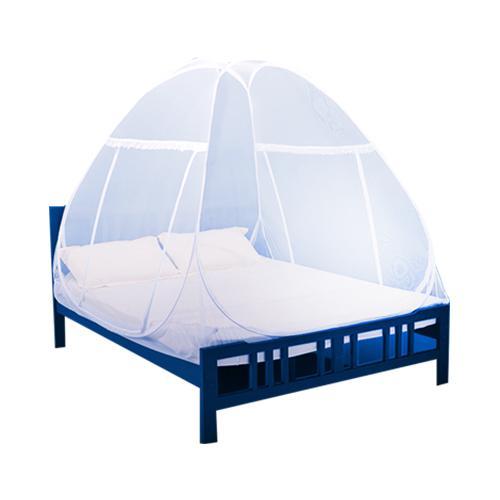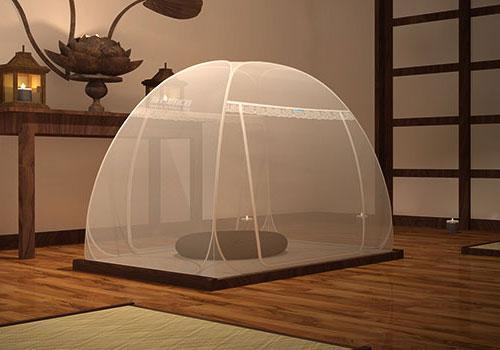The first image is the image on the left, the second image is the image on the right. Given the left and right images, does the statement "There are two canopies tents." hold true? Answer yes or no. Yes. The first image is the image on the left, the second image is the image on the right. Analyze the images presented: Is the assertion "In the image to the right, the bed-tent is white." valid? Answer yes or no. Yes. 